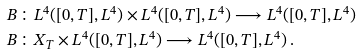Convert formula to latex. <formula><loc_0><loc_0><loc_500><loc_500>& B \colon L ^ { 4 } ( [ 0 , T ] , L ^ { 4 } ) \times L ^ { 4 } ( [ 0 , T ] , L ^ { 4 } ) \longrightarrow L ^ { 4 } ( [ 0 , T ] , L ^ { 4 } ) \\ & B \colon X _ { T } \times L ^ { 4 } ( [ 0 , T ] , L ^ { 4 } ) \longrightarrow L ^ { 4 } ( [ 0 , T ] , L ^ { 4 } ) \, . \\</formula> 